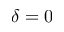<formula> <loc_0><loc_0><loc_500><loc_500>\delta = 0</formula> 